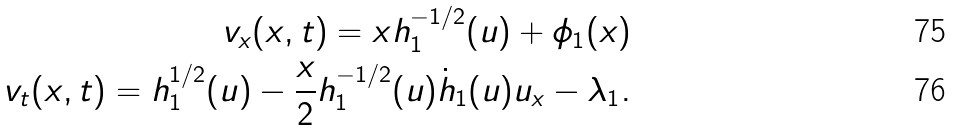<formula> <loc_0><loc_0><loc_500><loc_500>v _ { x } ( x , t ) = x h _ { 1 } ^ { - 1 / 2 } ( u ) + \phi _ { 1 } ( x ) \\ v _ { t } ( x , t ) = h _ { 1 } ^ { 1 / 2 } ( u ) - \frac { x } { 2 } h _ { 1 } ^ { - 1 / 2 } ( u ) \dot { h } _ { 1 } ( u ) u _ { x } - \lambda _ { 1 } .</formula> 